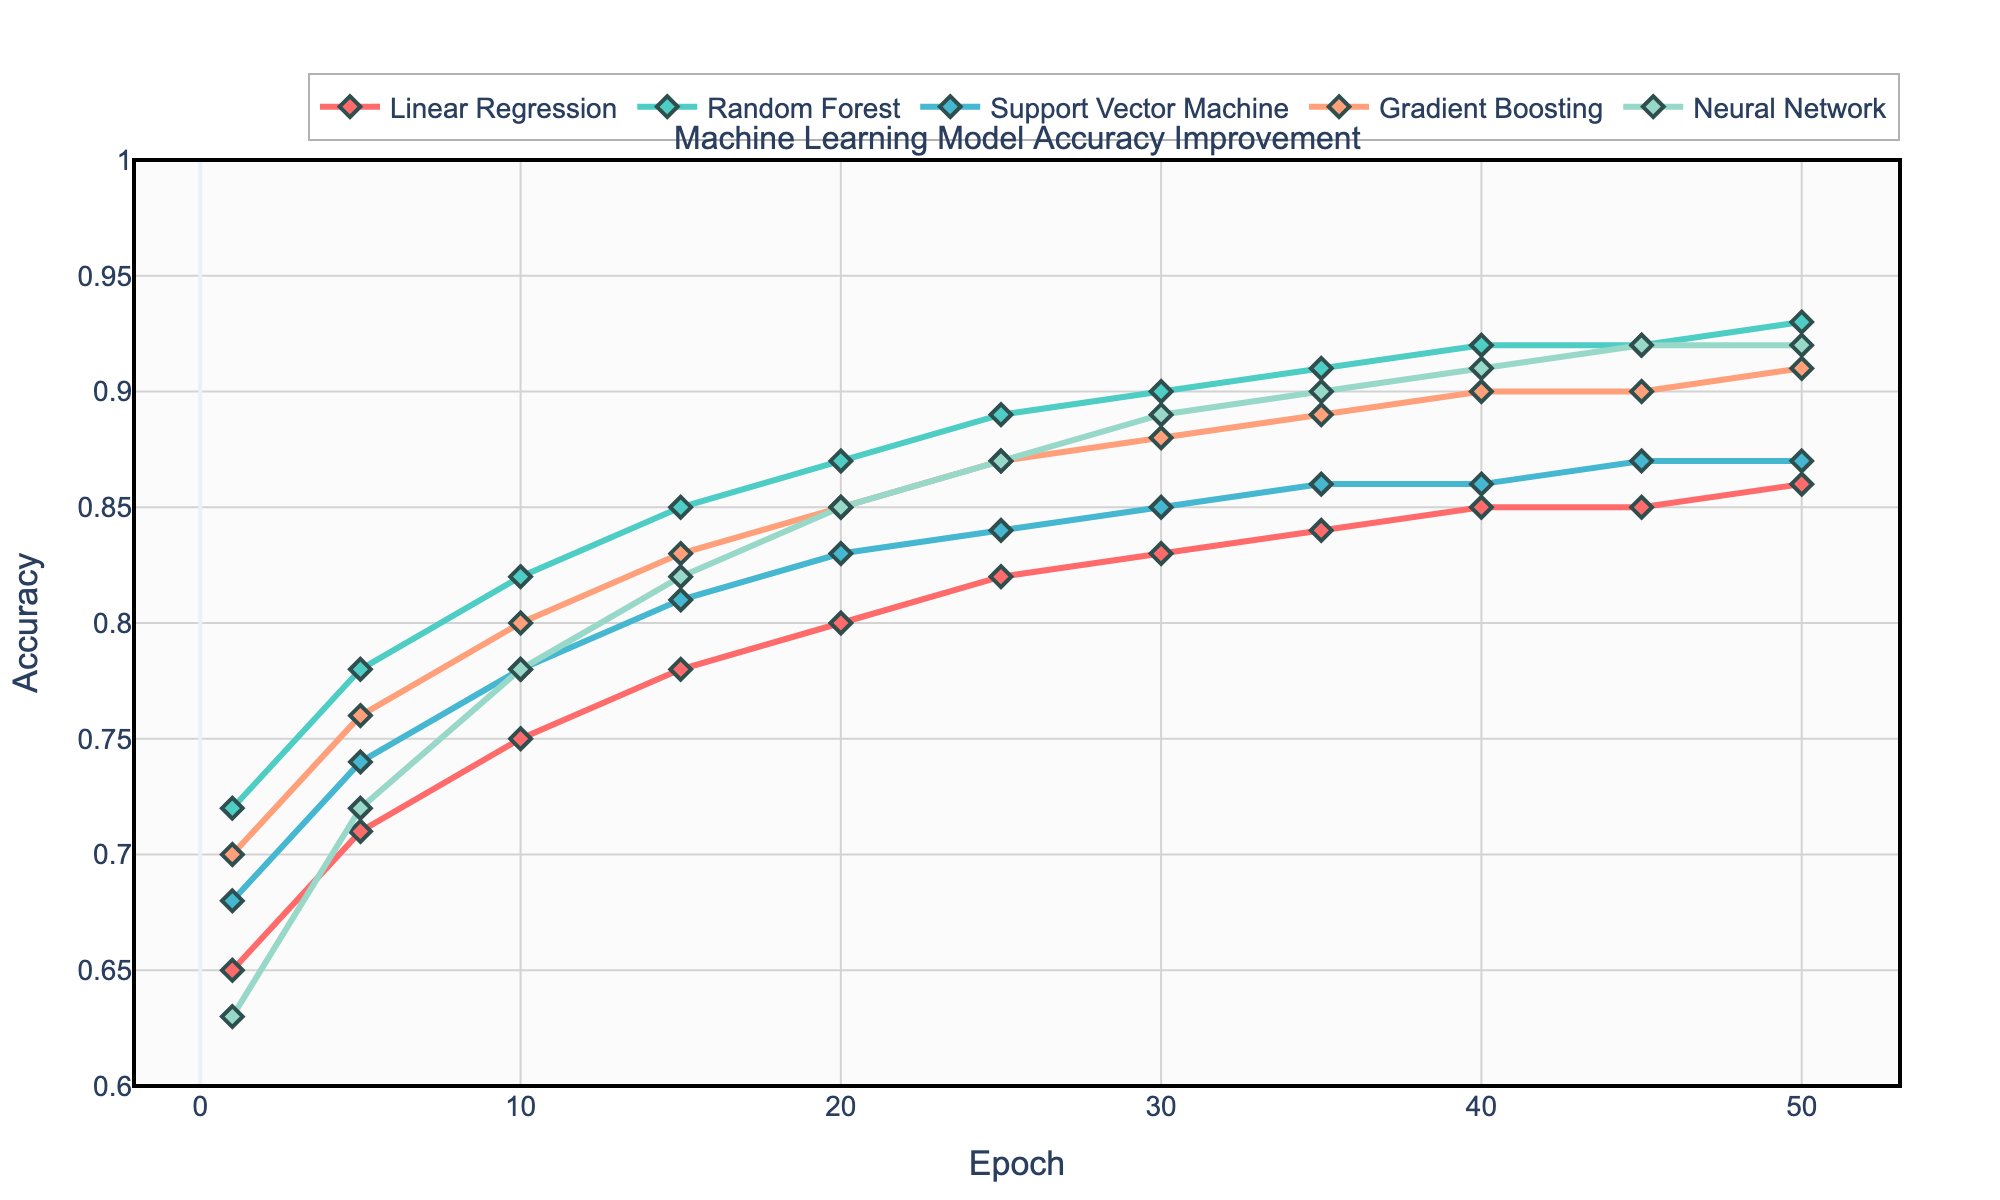Which algorithm shows the highest accuracy at epoch 50? Check the y-values at epoch 50 for each algorithm. The Neural Network shows the highest accuracy at 0.92.
Answer: Neural Network Which algorithm has the steepest initial improvement in accuracy between epochs 1 and 5? Calculate the accuracy difference between epochs 1 and 5 for each algorithm and compare. Random Forest has the highest increase (0.78 - 0.72 = 0.06).
Answer: Random Forest How does the accuracy of Linear Regression change from epoch 10 to epoch 20? Examine the y-values for Linear Regression at epochs 10 and 20. The accuracy increases from 0.75 to 0.80, an improvement of 0.05.
Answer: Increases by 0.05 By how much does the accuracy of the Support Vector Machine exceed that of Linear Regression at epoch 40? Find the y-values for both algorithms at epoch 40 and subtract. SVM is at 0.86, and Linear Regression is at 0.85, so the difference is 0.01.
Answer: 0.01 Which algorithm reaches an accuracy of 0.90 first? Check which algorithm reaches an accuracy of 0.90 at the earliest epoch. Random Forest reaches it at epoch 30.
Answer: Random Forest Among all the algorithms, which one shows the least improvement from epoch 1 to epoch 50? Subtract the accuracy at epoch 1 from the accuracy at epoch 50 for each algorithm and compare. Linear Regression shows the least improvement (0.86 - 0.65 = 0.21).
Answer: Linear Regression At epoch 35, which algorithm has the closest accuracy to the Neural Network? Check the y-values of all algorithms at epoch 35 and compare them to the Neural Network's value of 0.90. Gradient Boosting with 0.89 is the closest.
Answer: Gradient Boosting What is the average accuracy of Gradient Boosting across all epochs? Sum Gradient Boosting's accuracy values at all epochs and divide by the number of epochs. (0.70 + 0.76 + 0.80 + 0.83 + 0.85 + 0.87 + 0.88 + 0.89 + 0.90 + 0.90 + 0.91) / 11 = 0.84
Answer: 0.84 